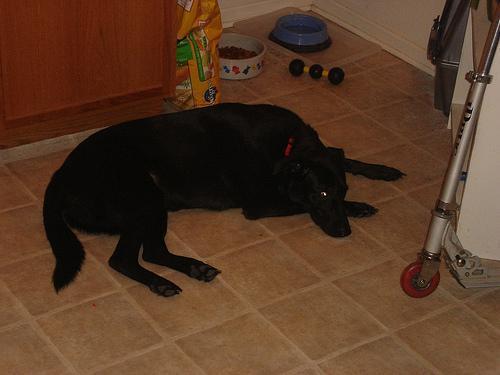How many dogs are there?
Give a very brief answer. 1. 